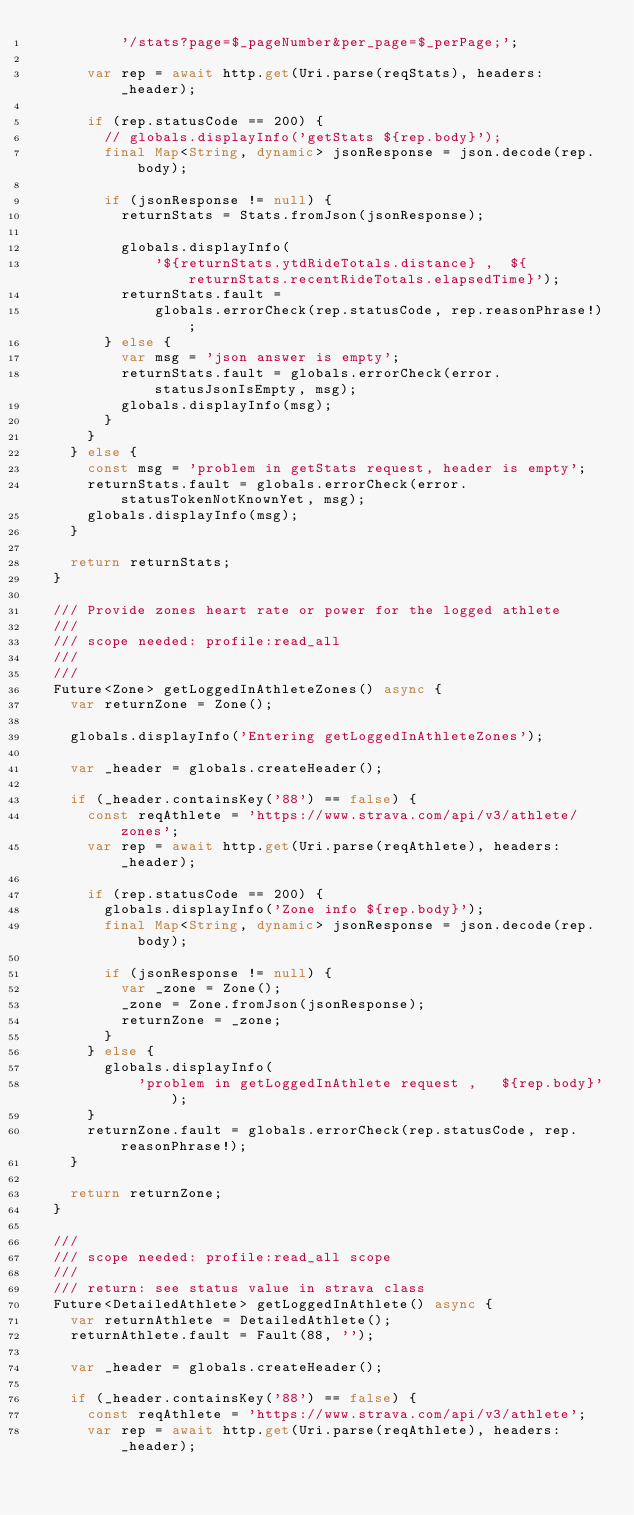Convert code to text. <code><loc_0><loc_0><loc_500><loc_500><_Dart_>          '/stats?page=$_pageNumber&per_page=$_perPage;';

      var rep = await http.get(Uri.parse(reqStats), headers: _header);

      if (rep.statusCode == 200) {
        // globals.displayInfo('getStats ${rep.body}');
        final Map<String, dynamic> jsonResponse = json.decode(rep.body);

        if (jsonResponse != null) {
          returnStats = Stats.fromJson(jsonResponse);

          globals.displayInfo(
              '${returnStats.ytdRideTotals.distance} ,  ${returnStats.recentRideTotals.elapsedTime}');
          returnStats.fault =
              globals.errorCheck(rep.statusCode, rep.reasonPhrase!);
        } else {
          var msg = 'json answer is empty';
          returnStats.fault = globals.errorCheck(error.statusJsonIsEmpty, msg);
          globals.displayInfo(msg);
        }
      }
    } else {
      const msg = 'problem in getStats request, header is empty';
      returnStats.fault = globals.errorCheck(error.statusTokenNotKnownYet, msg);
      globals.displayInfo(msg);
    }

    return returnStats;
  }

  /// Provide zones heart rate or power for the logged athlete
  ///
  /// scope needed: profile:read_all
  ///
  ///
  Future<Zone> getLoggedInAthleteZones() async {
    var returnZone = Zone();

    globals.displayInfo('Entering getLoggedInAthleteZones');

    var _header = globals.createHeader();

    if (_header.containsKey('88') == false) {
      const reqAthlete = 'https://www.strava.com/api/v3/athlete/zones';
      var rep = await http.get(Uri.parse(reqAthlete), headers: _header);

      if (rep.statusCode == 200) {
        globals.displayInfo('Zone info ${rep.body}');
        final Map<String, dynamic> jsonResponse = json.decode(rep.body);

        if (jsonResponse != null) {
          var _zone = Zone();
          _zone = Zone.fromJson(jsonResponse);
          returnZone = _zone;
        }
      } else {
        globals.displayInfo(
            'problem in getLoggedInAthlete request ,   ${rep.body}');
      }
      returnZone.fault = globals.errorCheck(rep.statusCode, rep.reasonPhrase!);
    }

    return returnZone;
  }

  ///
  /// scope needed: profile:read_all scope
  ///
  /// return: see status value in strava class
  Future<DetailedAthlete> getLoggedInAthlete() async {
    var returnAthlete = DetailedAthlete();
    returnAthlete.fault = Fault(88, '');

    var _header = globals.createHeader();

    if (_header.containsKey('88') == false) {
      const reqAthlete = 'https://www.strava.com/api/v3/athlete';
      var rep = await http.get(Uri.parse(reqAthlete), headers: _header);
</code> 